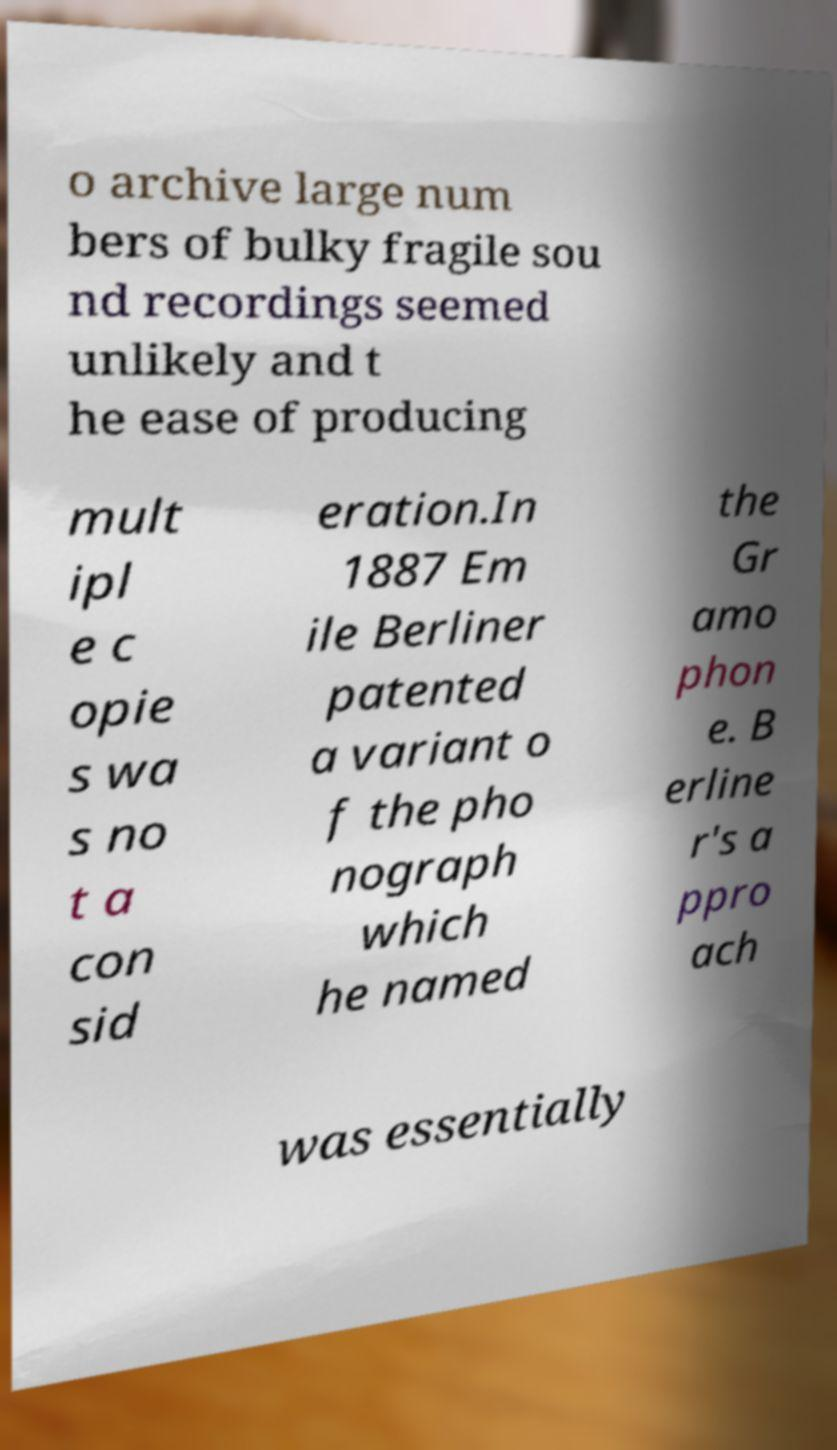Could you assist in decoding the text presented in this image and type it out clearly? o archive large num bers of bulky fragile sou nd recordings seemed unlikely and t he ease of producing mult ipl e c opie s wa s no t a con sid eration.In 1887 Em ile Berliner patented a variant o f the pho nograph which he named the Gr amo phon e. B erline r's a ppro ach was essentially 